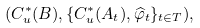<formula> <loc_0><loc_0><loc_500><loc_500>( C _ { u } ^ { \ast } ( B ) , \{ C _ { u } ^ { \ast } ( A _ { t } ) , \widehat { \varphi } _ { t } \} _ { t \in T } ) ,</formula> 